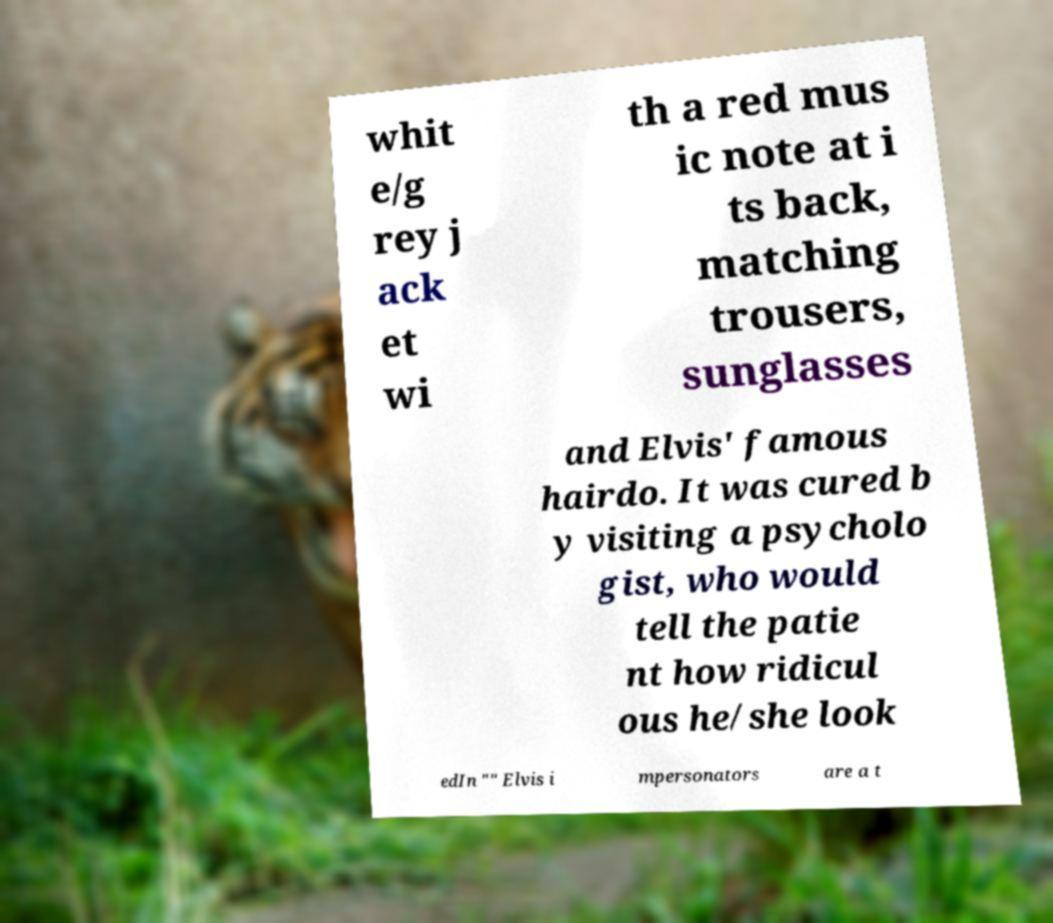I need the written content from this picture converted into text. Can you do that? whit e/g rey j ack et wi th a red mus ic note at i ts back, matching trousers, sunglasses and Elvis' famous hairdo. It was cured b y visiting a psycholo gist, who would tell the patie nt how ridicul ous he/she look edIn "" Elvis i mpersonators are a t 